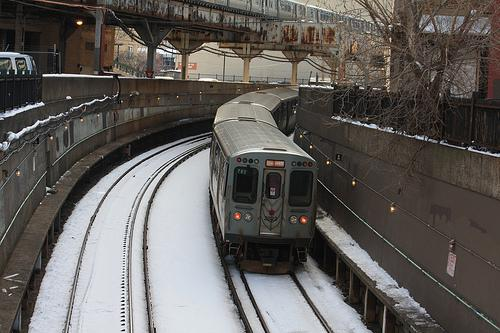Briefly describe the image in a humorous way. Winter's chill can't stop this silver train and its glowing red nose, racing like Santa's sleigh through the snow. Describe the color palette of the image. The color palette consists of silver, gray, white, and a touch of red from the train's light. Offer a short description of the image from the perspective of a passenger. Passing by a bare tree and across a rusty bridge, I glimpse the snow-covered tracks as the silver train chugs along its journey. Express the scene in a poetic way. Like a silver snake, the train slides along the ice-kissed rails, flanked by the haunting, branchy sentinel standing tall. Write a brief sentence about the image's weather and atmosphere. The snowy landscape creates a quiet and serene atmosphere around the train tracks. List three objects from the image and their visual characteristics. 3. Gray, leafless tree beside the tracks Write a haiku using elements from the image. Bare branches bow down. Mention the key features of the scene in a few words. Silver train on snow-covered tracks, bare tree, bridge, and red light on the train. Give a headline to the image as if it was from a news article. Train Braving Snow: Services Uninterrupted Despite Winter Conditions Mention an aspect of the train that stands out and a possible reason behind it. The red light on the train may serve as a warning signal for other vehicles or people near the tracks. 